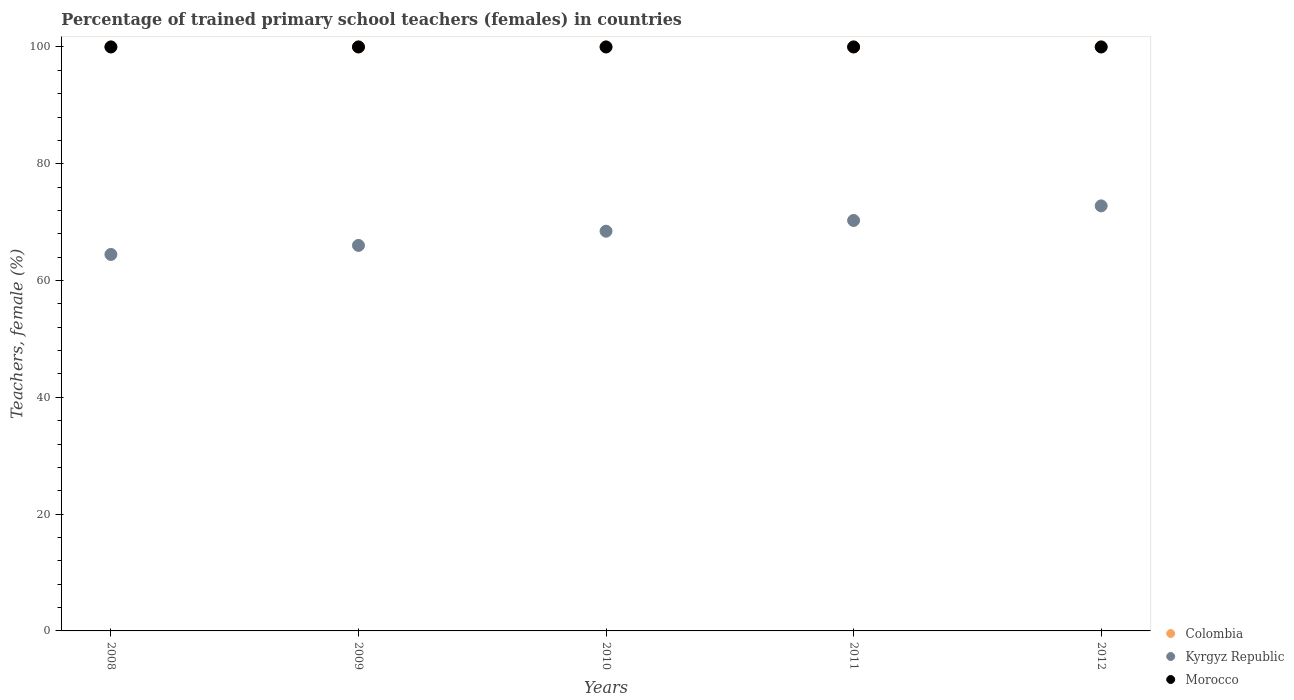How many different coloured dotlines are there?
Ensure brevity in your answer.  3. Across all years, what is the maximum percentage of trained primary school teachers (females) in Morocco?
Your answer should be compact. 100. In which year was the percentage of trained primary school teachers (females) in Colombia maximum?
Give a very brief answer. 2008. What is the total percentage of trained primary school teachers (females) in Kyrgyz Republic in the graph?
Provide a short and direct response. 342. What is the difference between the percentage of trained primary school teachers (females) in Kyrgyz Republic in 2008 and that in 2011?
Your answer should be compact. -5.82. What is the difference between the percentage of trained primary school teachers (females) in Colombia in 2011 and the percentage of trained primary school teachers (females) in Kyrgyz Republic in 2008?
Make the answer very short. 35.53. What is the average percentage of trained primary school teachers (females) in Kyrgyz Republic per year?
Offer a very short reply. 68.4. In the year 2010, what is the difference between the percentage of trained primary school teachers (females) in Kyrgyz Republic and percentage of trained primary school teachers (females) in Morocco?
Your answer should be very brief. -31.55. In how many years, is the percentage of trained primary school teachers (females) in Colombia greater than 92 %?
Your answer should be compact. 5. What is the ratio of the percentage of trained primary school teachers (females) in Morocco in 2008 to that in 2011?
Provide a short and direct response. 1. Is the percentage of trained primary school teachers (females) in Colombia in 2010 less than that in 2011?
Make the answer very short. No. Is the difference between the percentage of trained primary school teachers (females) in Kyrgyz Republic in 2008 and 2009 greater than the difference between the percentage of trained primary school teachers (females) in Morocco in 2008 and 2009?
Offer a terse response. No. What is the difference between the highest and the lowest percentage of trained primary school teachers (females) in Kyrgyz Republic?
Provide a succinct answer. 8.32. In how many years, is the percentage of trained primary school teachers (females) in Morocco greater than the average percentage of trained primary school teachers (females) in Morocco taken over all years?
Make the answer very short. 0. Is it the case that in every year, the sum of the percentage of trained primary school teachers (females) in Kyrgyz Republic and percentage of trained primary school teachers (females) in Morocco  is greater than the percentage of trained primary school teachers (females) in Colombia?
Keep it short and to the point. Yes. Is the percentage of trained primary school teachers (females) in Morocco strictly less than the percentage of trained primary school teachers (females) in Colombia over the years?
Your answer should be very brief. No. How many years are there in the graph?
Ensure brevity in your answer.  5. What is the difference between two consecutive major ticks on the Y-axis?
Your response must be concise. 20. Does the graph contain grids?
Ensure brevity in your answer.  No. Where does the legend appear in the graph?
Your response must be concise. Bottom right. What is the title of the graph?
Give a very brief answer. Percentage of trained primary school teachers (females) in countries. Does "Cambodia" appear as one of the legend labels in the graph?
Make the answer very short. No. What is the label or title of the X-axis?
Keep it short and to the point. Years. What is the label or title of the Y-axis?
Your response must be concise. Teachers, female (%). What is the Teachers, female (%) in Kyrgyz Republic in 2008?
Your answer should be very brief. 64.47. What is the Teachers, female (%) of Kyrgyz Republic in 2009?
Your answer should be compact. 66.01. What is the Teachers, female (%) in Colombia in 2010?
Ensure brevity in your answer.  100. What is the Teachers, female (%) of Kyrgyz Republic in 2010?
Your answer should be very brief. 68.45. What is the Teachers, female (%) in Colombia in 2011?
Provide a short and direct response. 100. What is the Teachers, female (%) of Kyrgyz Republic in 2011?
Your answer should be compact. 70.29. What is the Teachers, female (%) of Kyrgyz Republic in 2012?
Offer a terse response. 72.78. What is the Teachers, female (%) in Morocco in 2012?
Provide a short and direct response. 100. Across all years, what is the maximum Teachers, female (%) in Kyrgyz Republic?
Keep it short and to the point. 72.78. Across all years, what is the minimum Teachers, female (%) of Kyrgyz Republic?
Keep it short and to the point. 64.47. What is the total Teachers, female (%) of Kyrgyz Republic in the graph?
Give a very brief answer. 342. What is the total Teachers, female (%) in Morocco in the graph?
Ensure brevity in your answer.  500. What is the difference between the Teachers, female (%) in Colombia in 2008 and that in 2009?
Offer a terse response. 0. What is the difference between the Teachers, female (%) of Kyrgyz Republic in 2008 and that in 2009?
Keep it short and to the point. -1.55. What is the difference between the Teachers, female (%) in Kyrgyz Republic in 2008 and that in 2010?
Offer a very short reply. -3.98. What is the difference between the Teachers, female (%) of Colombia in 2008 and that in 2011?
Offer a terse response. 0. What is the difference between the Teachers, female (%) in Kyrgyz Republic in 2008 and that in 2011?
Your response must be concise. -5.82. What is the difference between the Teachers, female (%) in Colombia in 2008 and that in 2012?
Offer a very short reply. 0. What is the difference between the Teachers, female (%) in Kyrgyz Republic in 2008 and that in 2012?
Offer a very short reply. -8.32. What is the difference between the Teachers, female (%) in Colombia in 2009 and that in 2010?
Your response must be concise. 0. What is the difference between the Teachers, female (%) in Kyrgyz Republic in 2009 and that in 2010?
Your answer should be very brief. -2.43. What is the difference between the Teachers, female (%) of Kyrgyz Republic in 2009 and that in 2011?
Make the answer very short. -4.27. What is the difference between the Teachers, female (%) of Kyrgyz Republic in 2009 and that in 2012?
Make the answer very short. -6.77. What is the difference between the Teachers, female (%) in Morocco in 2009 and that in 2012?
Offer a terse response. 0. What is the difference between the Teachers, female (%) in Kyrgyz Republic in 2010 and that in 2011?
Make the answer very short. -1.84. What is the difference between the Teachers, female (%) of Morocco in 2010 and that in 2011?
Give a very brief answer. 0. What is the difference between the Teachers, female (%) in Kyrgyz Republic in 2010 and that in 2012?
Ensure brevity in your answer.  -4.34. What is the difference between the Teachers, female (%) in Kyrgyz Republic in 2011 and that in 2012?
Keep it short and to the point. -2.5. What is the difference between the Teachers, female (%) in Colombia in 2008 and the Teachers, female (%) in Kyrgyz Republic in 2009?
Your answer should be very brief. 33.99. What is the difference between the Teachers, female (%) of Colombia in 2008 and the Teachers, female (%) of Morocco in 2009?
Offer a very short reply. 0. What is the difference between the Teachers, female (%) in Kyrgyz Republic in 2008 and the Teachers, female (%) in Morocco in 2009?
Make the answer very short. -35.53. What is the difference between the Teachers, female (%) of Colombia in 2008 and the Teachers, female (%) of Kyrgyz Republic in 2010?
Ensure brevity in your answer.  31.55. What is the difference between the Teachers, female (%) of Colombia in 2008 and the Teachers, female (%) of Morocco in 2010?
Keep it short and to the point. 0. What is the difference between the Teachers, female (%) in Kyrgyz Republic in 2008 and the Teachers, female (%) in Morocco in 2010?
Your answer should be very brief. -35.53. What is the difference between the Teachers, female (%) in Colombia in 2008 and the Teachers, female (%) in Kyrgyz Republic in 2011?
Provide a succinct answer. 29.71. What is the difference between the Teachers, female (%) of Kyrgyz Republic in 2008 and the Teachers, female (%) of Morocco in 2011?
Make the answer very short. -35.53. What is the difference between the Teachers, female (%) in Colombia in 2008 and the Teachers, female (%) in Kyrgyz Republic in 2012?
Your answer should be very brief. 27.22. What is the difference between the Teachers, female (%) in Kyrgyz Republic in 2008 and the Teachers, female (%) in Morocco in 2012?
Your response must be concise. -35.53. What is the difference between the Teachers, female (%) in Colombia in 2009 and the Teachers, female (%) in Kyrgyz Republic in 2010?
Your answer should be compact. 31.55. What is the difference between the Teachers, female (%) of Colombia in 2009 and the Teachers, female (%) of Morocco in 2010?
Offer a very short reply. 0. What is the difference between the Teachers, female (%) in Kyrgyz Republic in 2009 and the Teachers, female (%) in Morocco in 2010?
Your answer should be very brief. -33.99. What is the difference between the Teachers, female (%) of Colombia in 2009 and the Teachers, female (%) of Kyrgyz Republic in 2011?
Ensure brevity in your answer.  29.71. What is the difference between the Teachers, female (%) of Kyrgyz Republic in 2009 and the Teachers, female (%) of Morocco in 2011?
Keep it short and to the point. -33.99. What is the difference between the Teachers, female (%) of Colombia in 2009 and the Teachers, female (%) of Kyrgyz Republic in 2012?
Your response must be concise. 27.22. What is the difference between the Teachers, female (%) of Colombia in 2009 and the Teachers, female (%) of Morocco in 2012?
Offer a very short reply. 0. What is the difference between the Teachers, female (%) of Kyrgyz Republic in 2009 and the Teachers, female (%) of Morocco in 2012?
Provide a succinct answer. -33.99. What is the difference between the Teachers, female (%) of Colombia in 2010 and the Teachers, female (%) of Kyrgyz Republic in 2011?
Give a very brief answer. 29.71. What is the difference between the Teachers, female (%) of Colombia in 2010 and the Teachers, female (%) of Morocco in 2011?
Your answer should be compact. 0. What is the difference between the Teachers, female (%) of Kyrgyz Republic in 2010 and the Teachers, female (%) of Morocco in 2011?
Ensure brevity in your answer.  -31.55. What is the difference between the Teachers, female (%) of Colombia in 2010 and the Teachers, female (%) of Kyrgyz Republic in 2012?
Ensure brevity in your answer.  27.22. What is the difference between the Teachers, female (%) in Kyrgyz Republic in 2010 and the Teachers, female (%) in Morocco in 2012?
Your response must be concise. -31.55. What is the difference between the Teachers, female (%) in Colombia in 2011 and the Teachers, female (%) in Kyrgyz Republic in 2012?
Give a very brief answer. 27.22. What is the difference between the Teachers, female (%) of Kyrgyz Republic in 2011 and the Teachers, female (%) of Morocco in 2012?
Make the answer very short. -29.71. What is the average Teachers, female (%) in Kyrgyz Republic per year?
Make the answer very short. 68.4. In the year 2008, what is the difference between the Teachers, female (%) in Colombia and Teachers, female (%) in Kyrgyz Republic?
Ensure brevity in your answer.  35.53. In the year 2008, what is the difference between the Teachers, female (%) of Colombia and Teachers, female (%) of Morocco?
Provide a succinct answer. 0. In the year 2008, what is the difference between the Teachers, female (%) in Kyrgyz Republic and Teachers, female (%) in Morocco?
Ensure brevity in your answer.  -35.53. In the year 2009, what is the difference between the Teachers, female (%) of Colombia and Teachers, female (%) of Kyrgyz Republic?
Your answer should be very brief. 33.99. In the year 2009, what is the difference between the Teachers, female (%) of Kyrgyz Republic and Teachers, female (%) of Morocco?
Your answer should be compact. -33.99. In the year 2010, what is the difference between the Teachers, female (%) of Colombia and Teachers, female (%) of Kyrgyz Republic?
Ensure brevity in your answer.  31.55. In the year 2010, what is the difference between the Teachers, female (%) in Kyrgyz Republic and Teachers, female (%) in Morocco?
Offer a terse response. -31.55. In the year 2011, what is the difference between the Teachers, female (%) in Colombia and Teachers, female (%) in Kyrgyz Republic?
Your response must be concise. 29.71. In the year 2011, what is the difference between the Teachers, female (%) in Kyrgyz Republic and Teachers, female (%) in Morocco?
Your response must be concise. -29.71. In the year 2012, what is the difference between the Teachers, female (%) in Colombia and Teachers, female (%) in Kyrgyz Republic?
Provide a succinct answer. 27.22. In the year 2012, what is the difference between the Teachers, female (%) of Kyrgyz Republic and Teachers, female (%) of Morocco?
Offer a terse response. -27.22. What is the ratio of the Teachers, female (%) in Kyrgyz Republic in 2008 to that in 2009?
Your answer should be compact. 0.98. What is the ratio of the Teachers, female (%) of Colombia in 2008 to that in 2010?
Your answer should be compact. 1. What is the ratio of the Teachers, female (%) in Kyrgyz Republic in 2008 to that in 2010?
Your answer should be compact. 0.94. What is the ratio of the Teachers, female (%) in Morocco in 2008 to that in 2010?
Offer a very short reply. 1. What is the ratio of the Teachers, female (%) in Colombia in 2008 to that in 2011?
Keep it short and to the point. 1. What is the ratio of the Teachers, female (%) of Kyrgyz Republic in 2008 to that in 2011?
Offer a very short reply. 0.92. What is the ratio of the Teachers, female (%) of Kyrgyz Republic in 2008 to that in 2012?
Ensure brevity in your answer.  0.89. What is the ratio of the Teachers, female (%) in Morocco in 2008 to that in 2012?
Provide a short and direct response. 1. What is the ratio of the Teachers, female (%) of Colombia in 2009 to that in 2010?
Offer a terse response. 1. What is the ratio of the Teachers, female (%) in Kyrgyz Republic in 2009 to that in 2010?
Provide a short and direct response. 0.96. What is the ratio of the Teachers, female (%) in Morocco in 2009 to that in 2010?
Offer a very short reply. 1. What is the ratio of the Teachers, female (%) in Colombia in 2009 to that in 2011?
Your response must be concise. 1. What is the ratio of the Teachers, female (%) in Kyrgyz Republic in 2009 to that in 2011?
Keep it short and to the point. 0.94. What is the ratio of the Teachers, female (%) of Morocco in 2009 to that in 2011?
Make the answer very short. 1. What is the ratio of the Teachers, female (%) of Colombia in 2009 to that in 2012?
Your answer should be compact. 1. What is the ratio of the Teachers, female (%) in Kyrgyz Republic in 2009 to that in 2012?
Ensure brevity in your answer.  0.91. What is the ratio of the Teachers, female (%) of Colombia in 2010 to that in 2011?
Offer a very short reply. 1. What is the ratio of the Teachers, female (%) of Kyrgyz Republic in 2010 to that in 2011?
Provide a succinct answer. 0.97. What is the ratio of the Teachers, female (%) in Morocco in 2010 to that in 2011?
Ensure brevity in your answer.  1. What is the ratio of the Teachers, female (%) of Kyrgyz Republic in 2010 to that in 2012?
Your answer should be compact. 0.94. What is the ratio of the Teachers, female (%) of Morocco in 2010 to that in 2012?
Provide a succinct answer. 1. What is the ratio of the Teachers, female (%) in Colombia in 2011 to that in 2012?
Your answer should be compact. 1. What is the ratio of the Teachers, female (%) of Kyrgyz Republic in 2011 to that in 2012?
Your answer should be very brief. 0.97. What is the ratio of the Teachers, female (%) in Morocco in 2011 to that in 2012?
Provide a succinct answer. 1. What is the difference between the highest and the second highest Teachers, female (%) in Colombia?
Offer a very short reply. 0. What is the difference between the highest and the second highest Teachers, female (%) of Kyrgyz Republic?
Offer a very short reply. 2.5. What is the difference between the highest and the second highest Teachers, female (%) of Morocco?
Your answer should be very brief. 0. What is the difference between the highest and the lowest Teachers, female (%) of Colombia?
Offer a terse response. 0. What is the difference between the highest and the lowest Teachers, female (%) in Kyrgyz Republic?
Offer a terse response. 8.32. What is the difference between the highest and the lowest Teachers, female (%) in Morocco?
Your answer should be very brief. 0. 